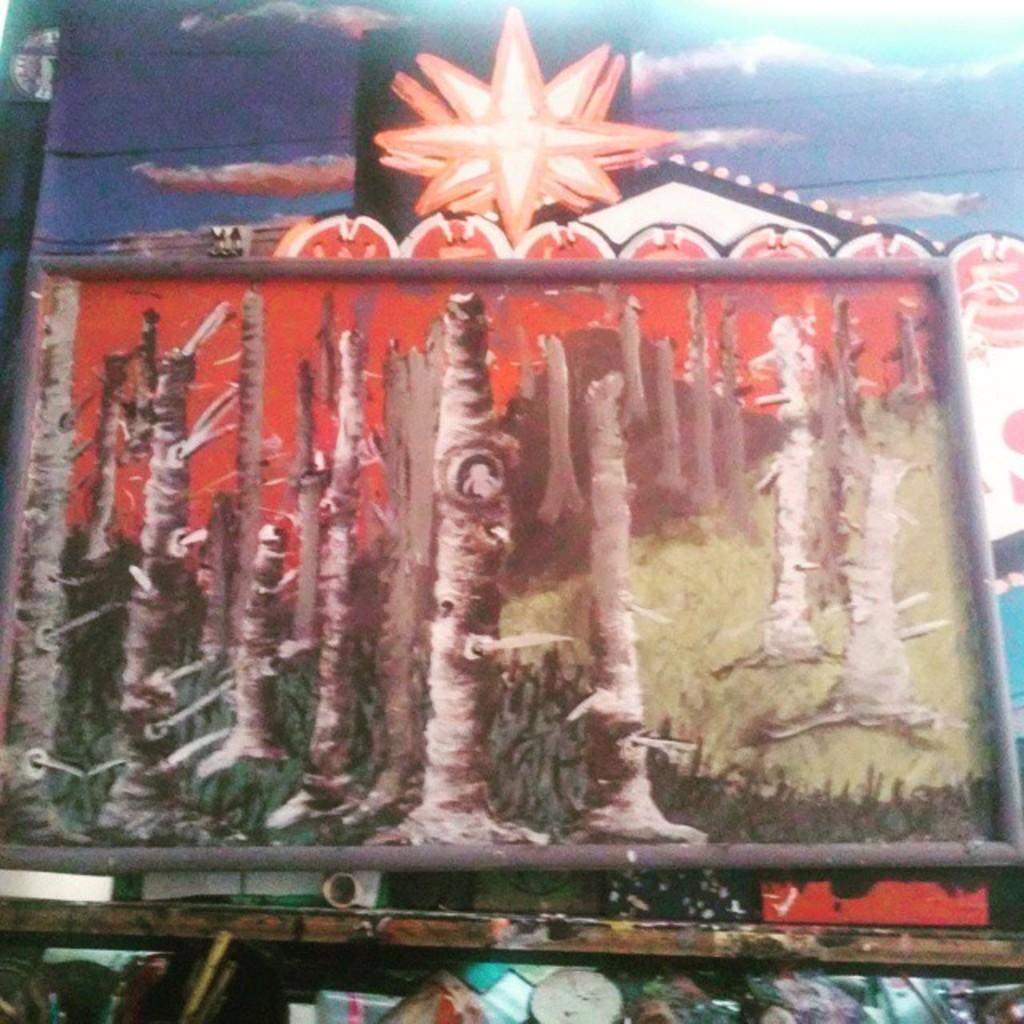In one or two sentences, can you explain what this image depicts? In this image, we can see some boards and in the background, there is a painting on the wall. 